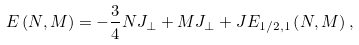<formula> <loc_0><loc_0><loc_500><loc_500>E \left ( N , M \right ) = - \frac { 3 } { 4 } N J _ { \perp } + M J _ { \perp } + J E _ { 1 / 2 , 1 } \left ( N , M \right ) ,</formula> 